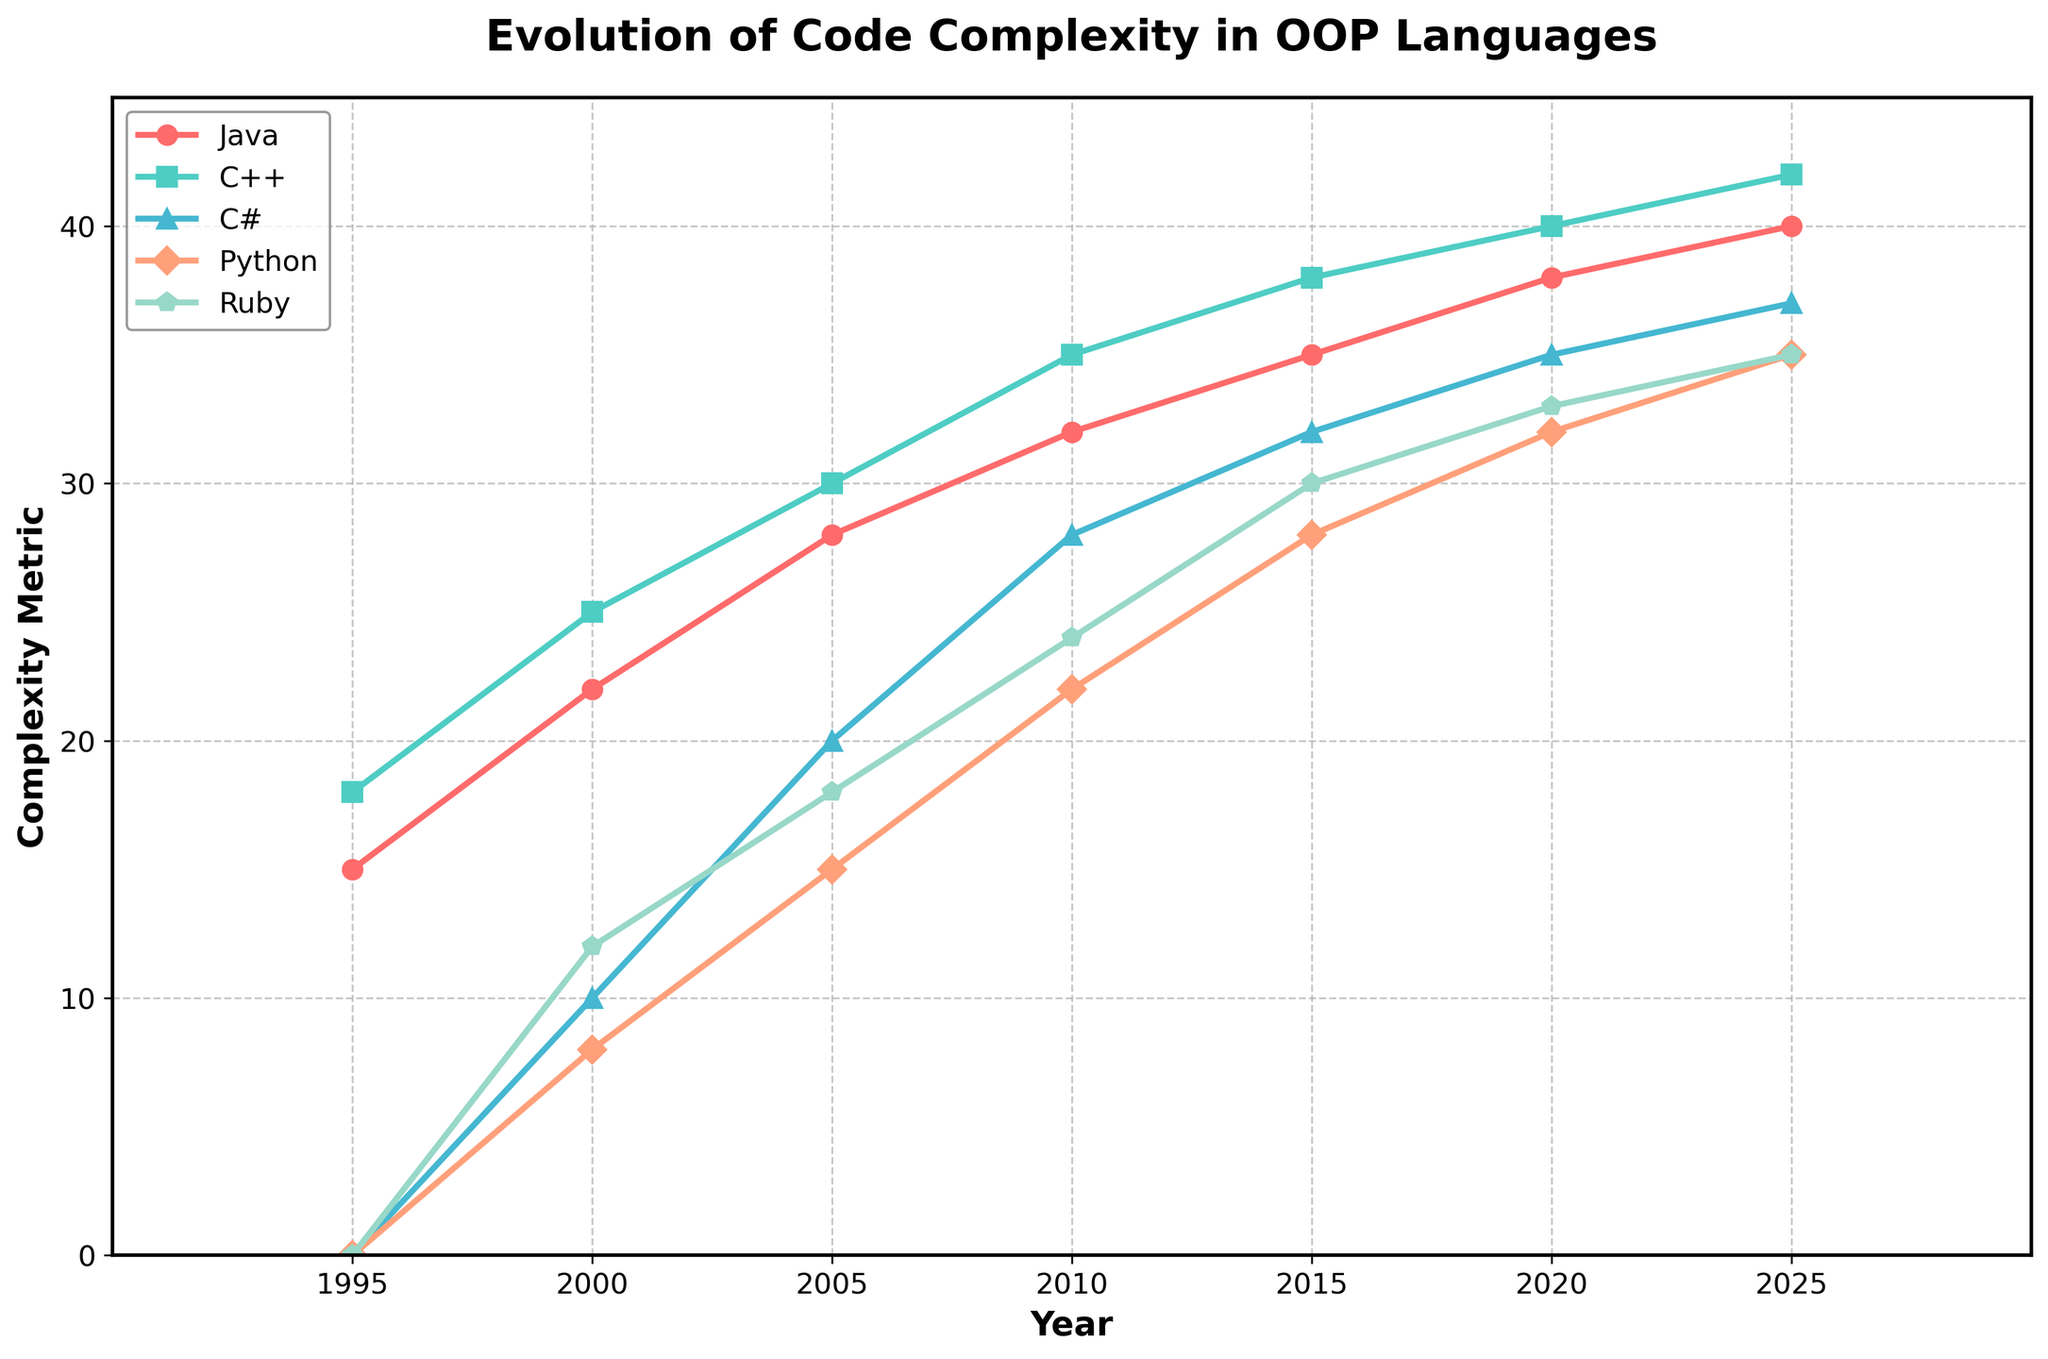What was the complexity metric for Python in 2010? From the figure, observe the point on the Python (dark green) line corresponding to the year 2010. This point is at the value of 22.
Answer: 22 Which language had the highest complexity metric in 2015? Look at the year 2015 on the X-axis, then compare the Y-axis values of all the languages. The C++ (light green) line is highest, which indicates its complexity metric is the greatest at 38.
Answer: C++ How many years after 2000 does Ruby's complexity metric surpass 30? Find the year 2000 on the X-axis and look at the Ruby (purple) line moving rightward. Ruby's complexity metric surpasses 30 in 2015, which is 15 years after 2000.
Answer: 15 years What is the difference in complexity metric between Java and C# in 2020? Look at the year 2020 and find the corresponding values for Java (red) and C# (blue). Java's value is 38, and C#'s value is 35. The difference is 38 - 35 = 3.
Answer: 3 In which year did Python first surpass a complexity metric of 20? Follow the Python (dark green) line and determine when it first crosses the value 20 on the Y-axis. This occurs around the year 2010.
Answer: 2010 What is the average complexity metric of Ruby across all the years shown? Sum the Ruby (purple) values: 0 + 12 + 18 + 24 + 30 + 33 + 35 = 152. There are 7 years, so the average is 152 / 7 ≈21.71.
Answer: ≈21.71 Which language had the most significant increase in complexity metric from 2000 to 2025? Identify the starting and ending values for each language: Java (22 to 40), C++ (25 to 42), C# (10 to 37), Python (8 to 35), Ruby (12 to 35). Calculate the increases: Java = 18, C++ = 17, C# = 27, Python = 27, Ruby = 23. The largest increases are C# and Python at 27.
Answer: C# and Python What was the median complexity metric of all languages in the year 2005? List the 2005 values for each language: 28 (Java), 30 (C++), 20 (C#), 15 (Python), 18 (Ruby). Arrange them in order: 15, 18, 20, 28, 30. The median value is 20.
Answer: 20 